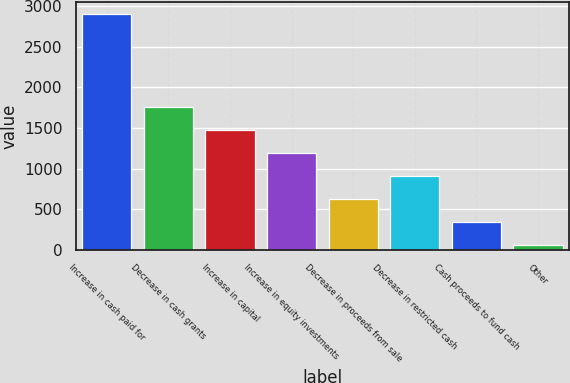<chart> <loc_0><loc_0><loc_500><loc_500><bar_chart><fcel>Increase in cash paid for<fcel>Decrease in cash grants<fcel>Increase in capital<fcel>Increase in equity investments<fcel>Decrease in proceeds from sale<fcel>Decrease in restricted cash<fcel>Cash proceeds to fund cash<fcel>Other<nl><fcel>2905<fcel>1764.6<fcel>1479.5<fcel>1194.4<fcel>624.2<fcel>909.3<fcel>339.1<fcel>54<nl></chart> 